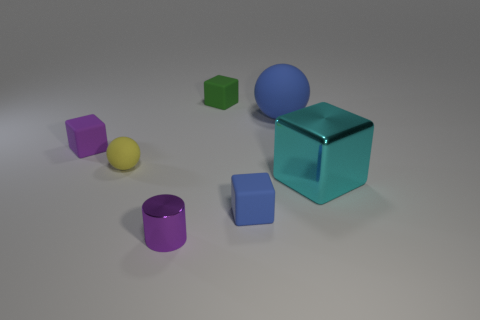There is a cube that is in front of the tiny sphere and to the left of the big blue matte ball; what is its color?
Your response must be concise. Blue. How many objects are tiny green rubber blocks or yellow spheres?
Provide a short and direct response. 2. What number of big things are either blue rubber objects or cyan things?
Your response must be concise. 2. Is there any other thing that has the same color as the tiny matte ball?
Your answer should be compact. No. What is the size of the cube that is behind the tiny blue cube and in front of the yellow matte sphere?
Keep it short and to the point. Large. There is a matte ball that is behind the tiny purple block; is it the same color as the tiny rubber thing in front of the cyan metal cube?
Ensure brevity in your answer.  Yes. How many other things are made of the same material as the green thing?
Keep it short and to the point. 4. What shape is the matte object that is both in front of the small purple matte cube and to the right of the small yellow matte object?
Make the answer very short. Cube. Does the small metal cylinder have the same color as the rubber block on the left side of the yellow rubber ball?
Keep it short and to the point. Yes. There is a matte cube on the right side of the green matte object; is its size the same as the large cyan thing?
Make the answer very short. No. 